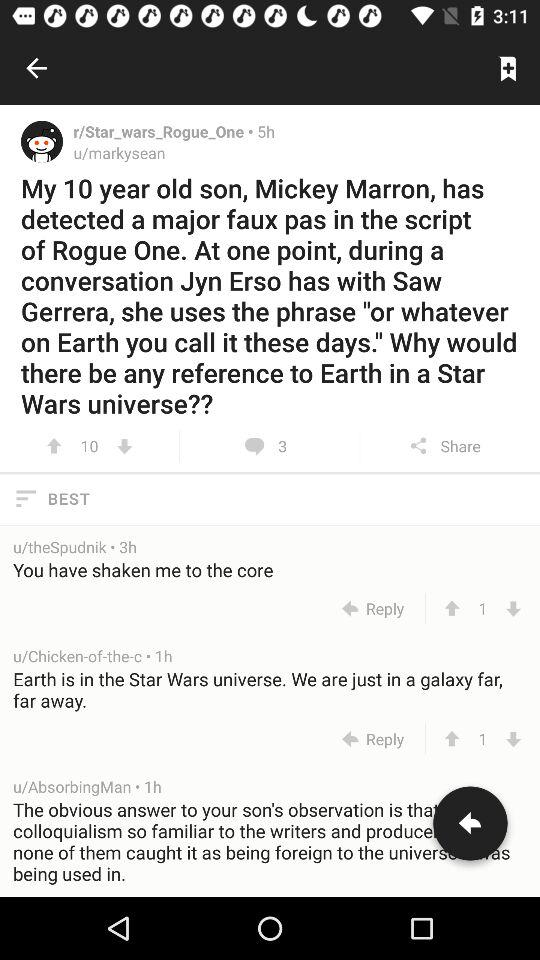How many comments are there for the given post? There are 3 comments for the given post. 